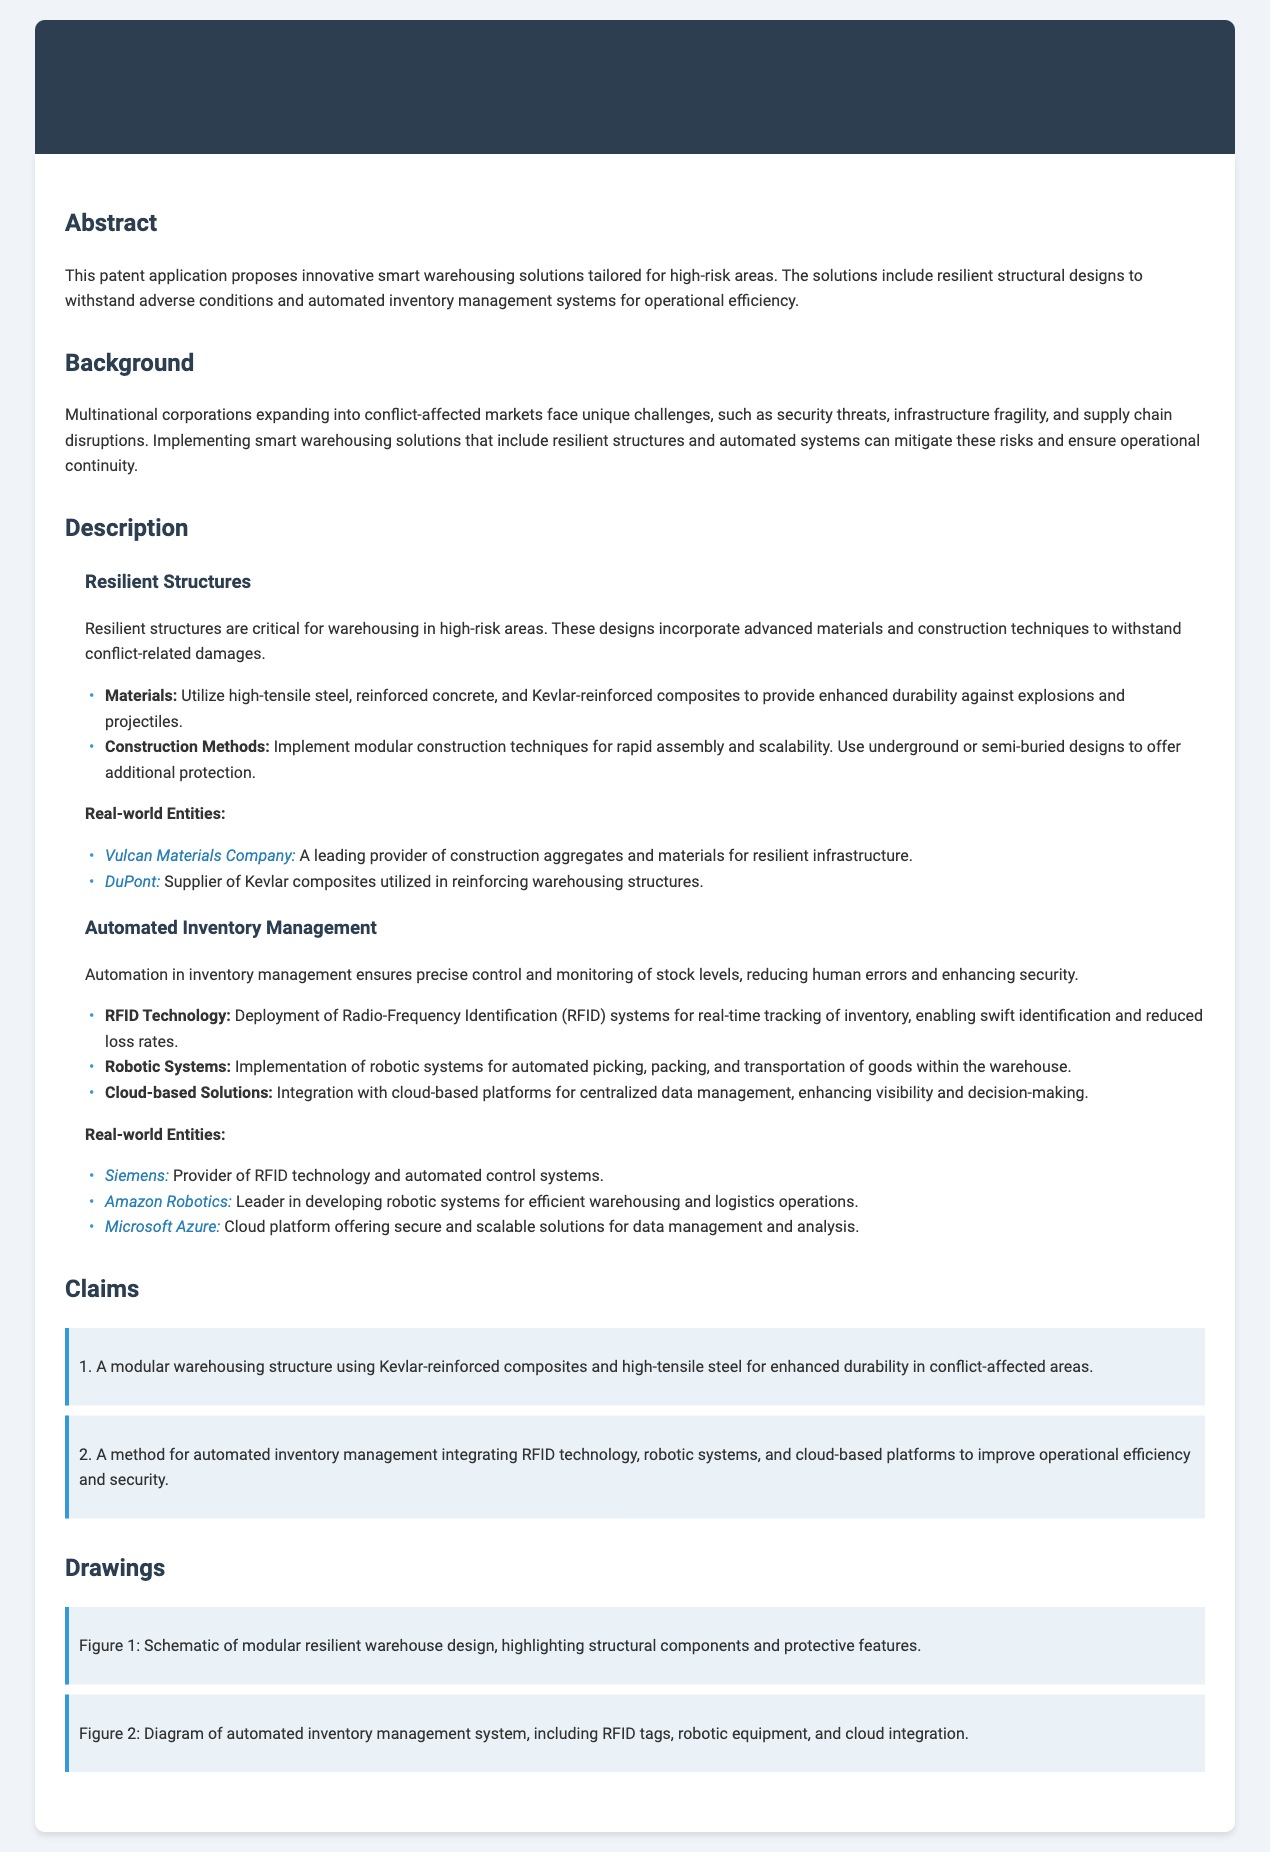What are the primary materials used in resilient structures? The document lists high-tensile steel, reinforced concrete, and Kevlar-reinforced composites as the primary materials.
Answer: high-tensile steel, reinforced concrete, Kevlar-reinforced composites Which company supplies Kevlar composites? The document mentions DuPont as the supplier of Kevlar composites utilized in reinforcing warehousing structures.
Answer: DuPont What is one benefit of automated inventory management mentioned? The document states that automation ensures precise control and monitoring of stock levels, reducing human errors and enhancing security.
Answer: reducing human errors What are the two types of construction methods described? The document refers to modular construction techniques and underground or semi-buried designs as the two types of construction methods.
Answer: modular construction techniques, underground or semi-buried designs How many claims are listed in this patent application? The document outlines two specific claims related to warehousing structures and inventory management methods.
Answer: 2 What technology is used for real-time tracking of inventory? According to the document, Radio-Frequency Identification (RFID) technology is employed for real-time tracking.
Answer: Radio-Frequency Identification (RFID) What advantage does the cloud-based integration provide? The document indicates that cloud-based solutions enhance visibility and decision-making.
Answer: enhance visibility and decision-making In which section is “Automated Inventory Management” discussed? The section labeled “Description” includes a subsection specifically for “Automated Inventory Management.”
Answer: Description 